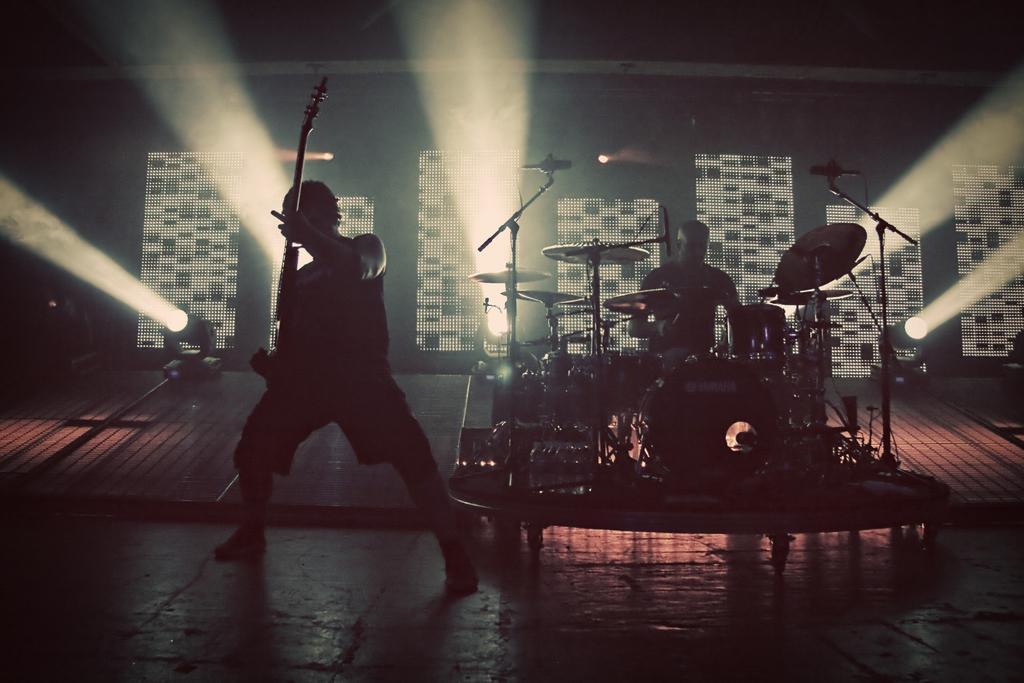Describe this image in one or two sentences. In this image There are two men. One man is standing and playing guitar and the other man is sitting and playing drums. At background I can see a show light and this looks like a stage performance. 